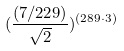<formula> <loc_0><loc_0><loc_500><loc_500>( \frac { ( 7 / 2 2 9 ) } { \sqrt { 2 } } ) ^ { ( 2 8 9 \cdot 3 ) }</formula> 